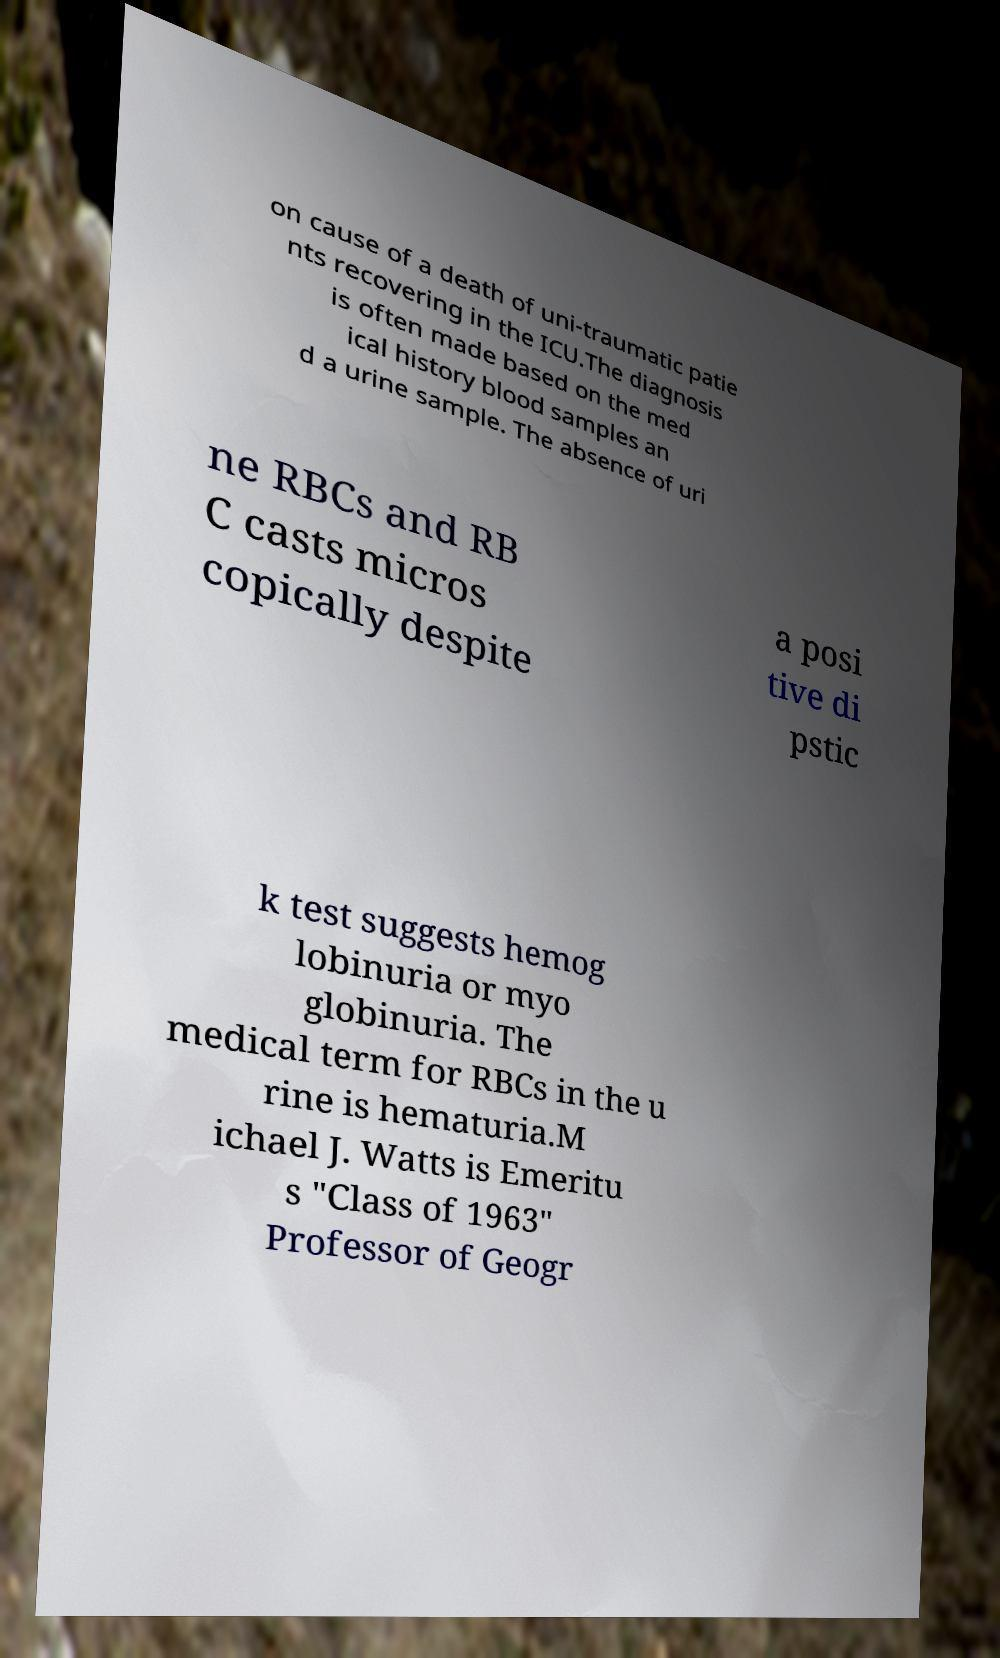For documentation purposes, I need the text within this image transcribed. Could you provide that? on cause of a death of uni-traumatic patie nts recovering in the ICU.The diagnosis is often made based on the med ical history blood samples an d a urine sample. The absence of uri ne RBCs and RB C casts micros copically despite a posi tive di pstic k test suggests hemog lobinuria or myo globinuria. The medical term for RBCs in the u rine is hematuria.M ichael J. Watts is Emeritu s "Class of 1963" Professor of Geogr 